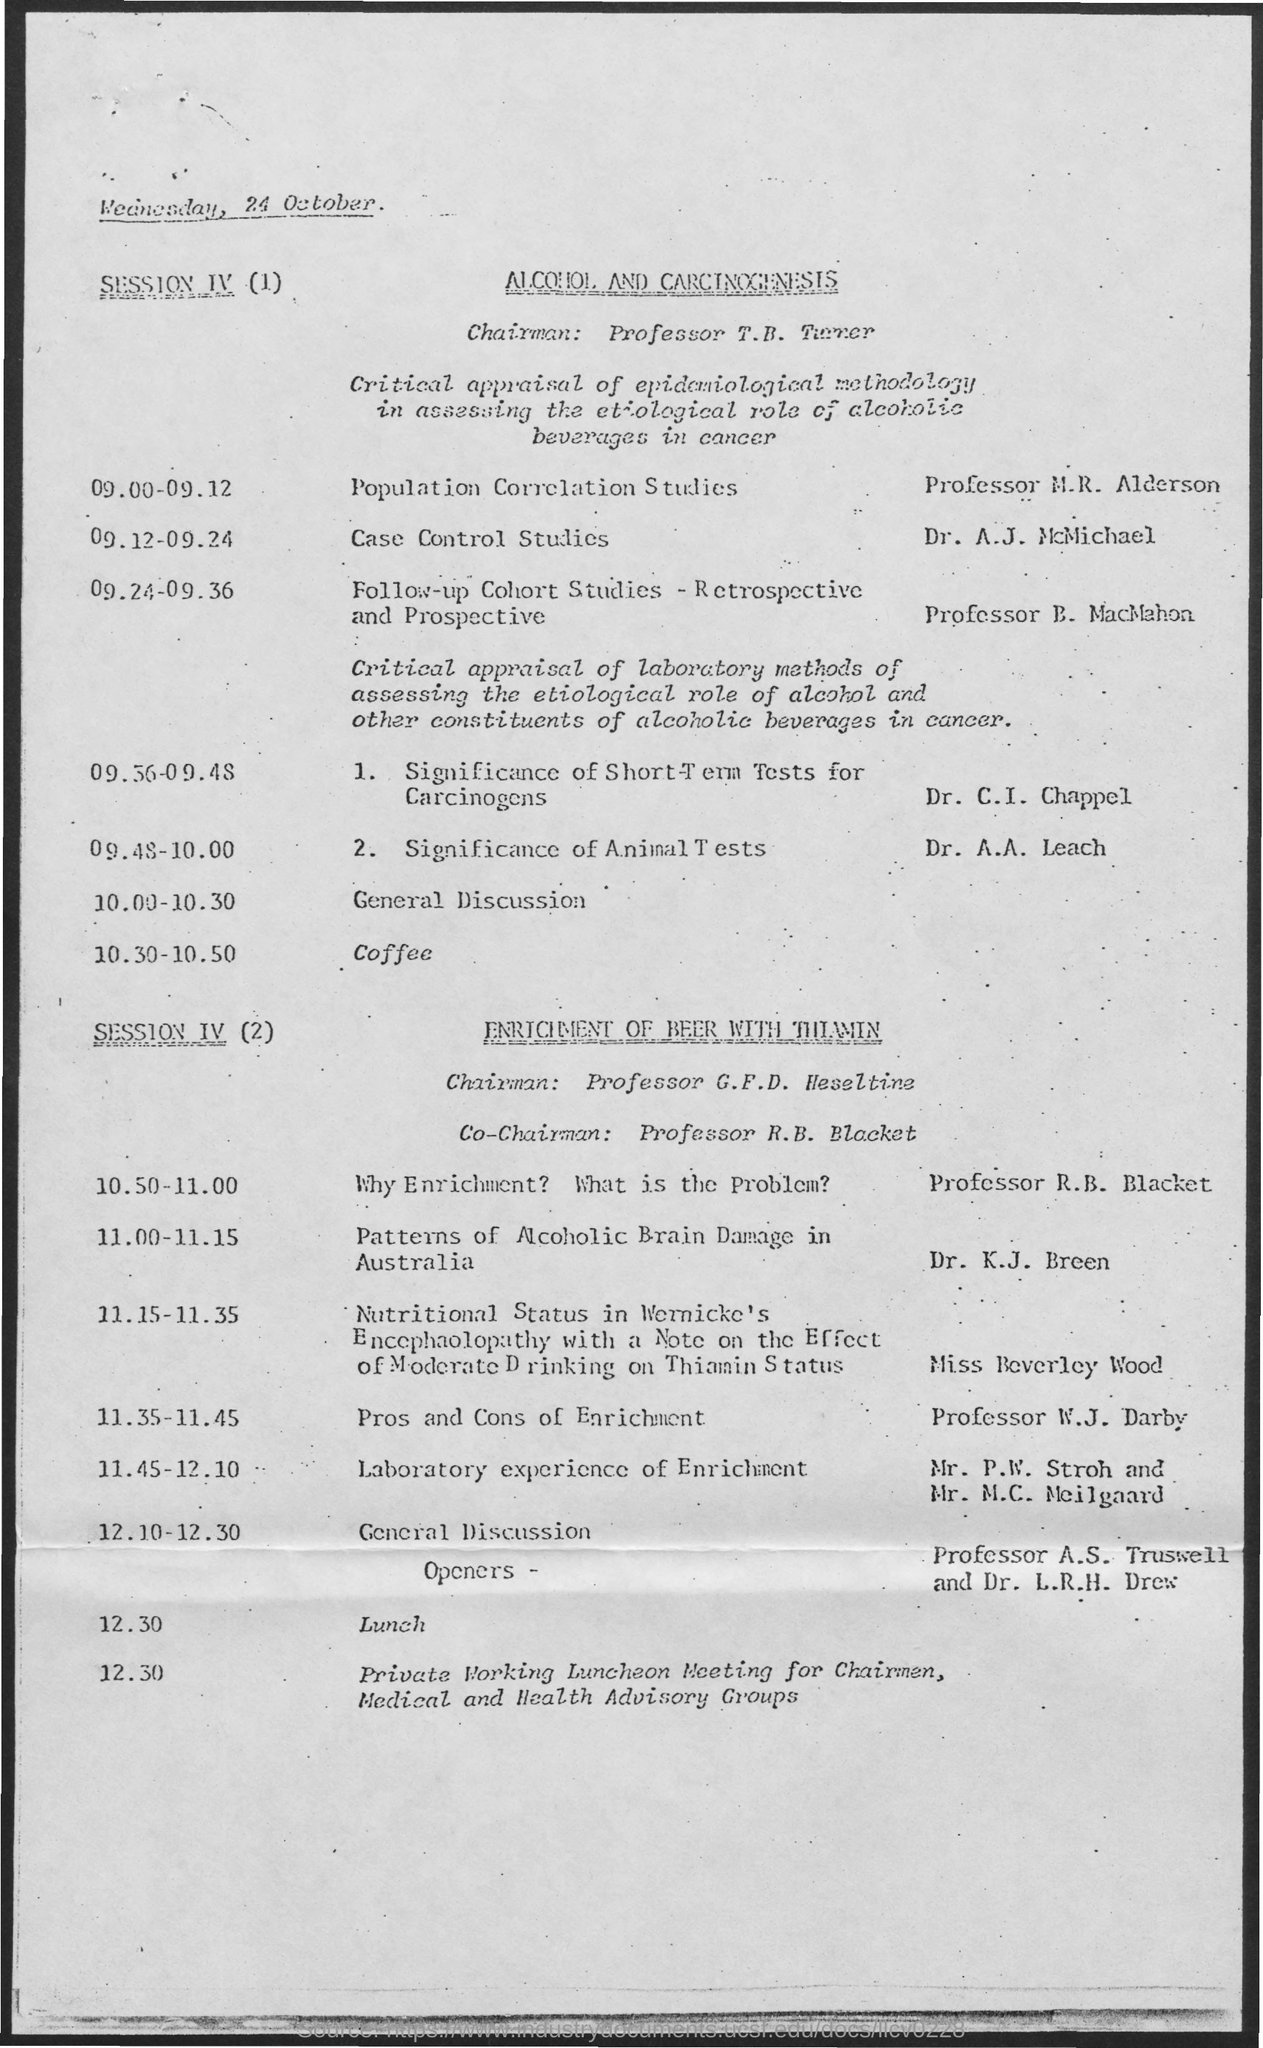When is the document dated?
Your response must be concise. Wednesday, 24 October. What is SESSION IV (1) on?
Offer a very short reply. ALCOHOL AND CARCINOGENESIS. What is the event from 09.00-09.12?
Your response must be concise. Population Correlation Studies. Who is taking Case Control Studies?
Give a very brief answer. Dr. A.J. McMichael. At what time is the "Patterns of Alcoholic Brain Damage in Australia"?
Make the answer very short. 11.00-11.15. Who is the chairman for SESSION IV (2)?
Your response must be concise. Professor G.F.D. Heseltine. 